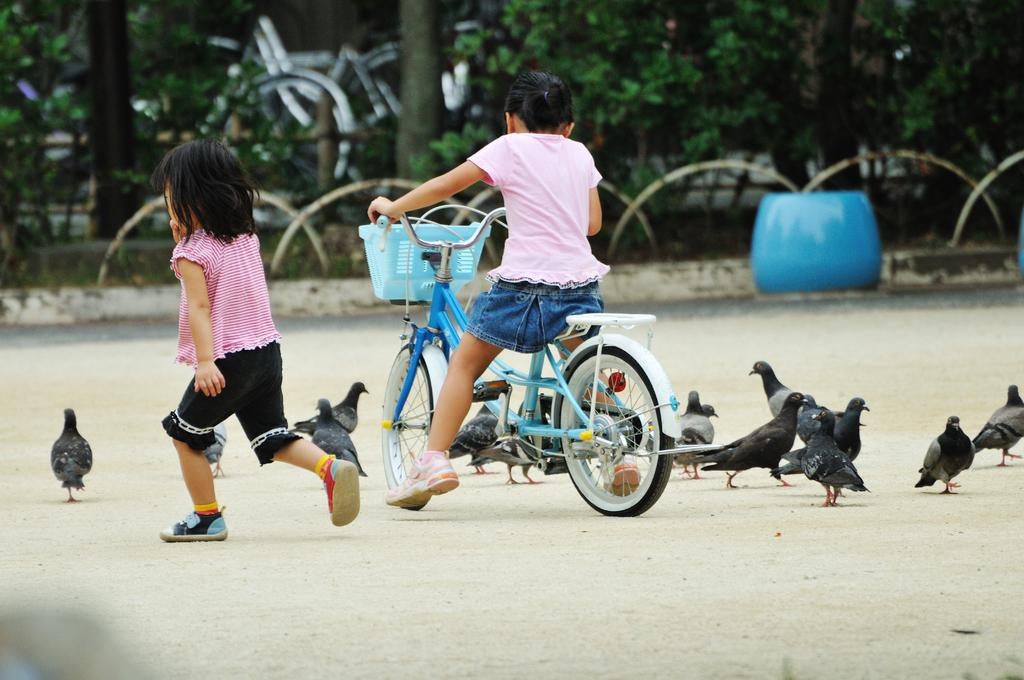How many children are present in the image? There are two children in the image. What is one of the children doing in the image? One of the children is riding a bicycle. What type of animals can be seen in the image? There are pigeons in the image. What type of vegetation is present in the image? There are plants and trees in the image. How many bikes are being ridden by the children in the image? There is only one child riding a bicycle in the image, so there is only one bike being ridden. What act is the toe performing in the image? There is no mention of a toe or any act involving a toe in the image. 